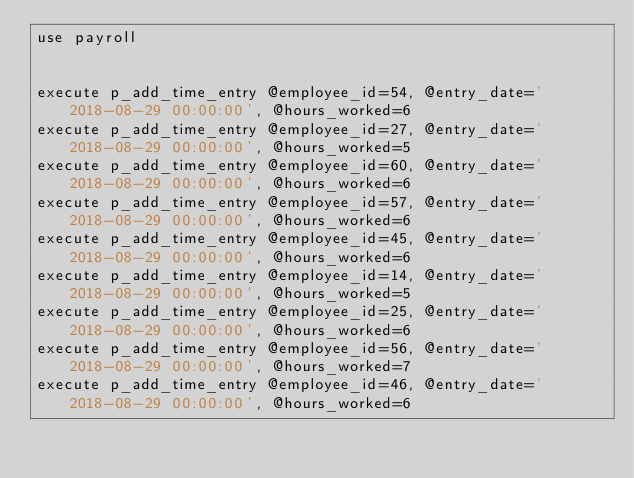Convert code to text. <code><loc_0><loc_0><loc_500><loc_500><_SQL_>use payroll


execute p_add_time_entry @employee_id=54, @entry_date='2018-08-29 00:00:00', @hours_worked=6
execute p_add_time_entry @employee_id=27, @entry_date='2018-08-29 00:00:00', @hours_worked=5
execute p_add_time_entry @employee_id=60, @entry_date='2018-08-29 00:00:00', @hours_worked=6
execute p_add_time_entry @employee_id=57, @entry_date='2018-08-29 00:00:00', @hours_worked=6
execute p_add_time_entry @employee_id=45, @entry_date='2018-08-29 00:00:00', @hours_worked=6
execute p_add_time_entry @employee_id=14, @entry_date='2018-08-29 00:00:00', @hours_worked=5
execute p_add_time_entry @employee_id=25, @entry_date='2018-08-29 00:00:00', @hours_worked=6
execute p_add_time_entry @employee_id=56, @entry_date='2018-08-29 00:00:00', @hours_worked=7
execute p_add_time_entry @employee_id=46, @entry_date='2018-08-29 00:00:00', @hours_worked=6

</code> 